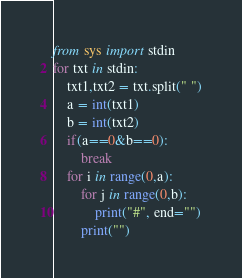Convert code to text. <code><loc_0><loc_0><loc_500><loc_500><_Python_>from sys import stdin
for txt in stdin:
    txt1,txt2 = txt.split(" ")
    a = int(txt1)
    b = int(txt2)
    if(a==0&b==0):
        break
    for i in range(0,a):
        for j in range(0,b):
            print("#", end="")
        print("")

</code> 